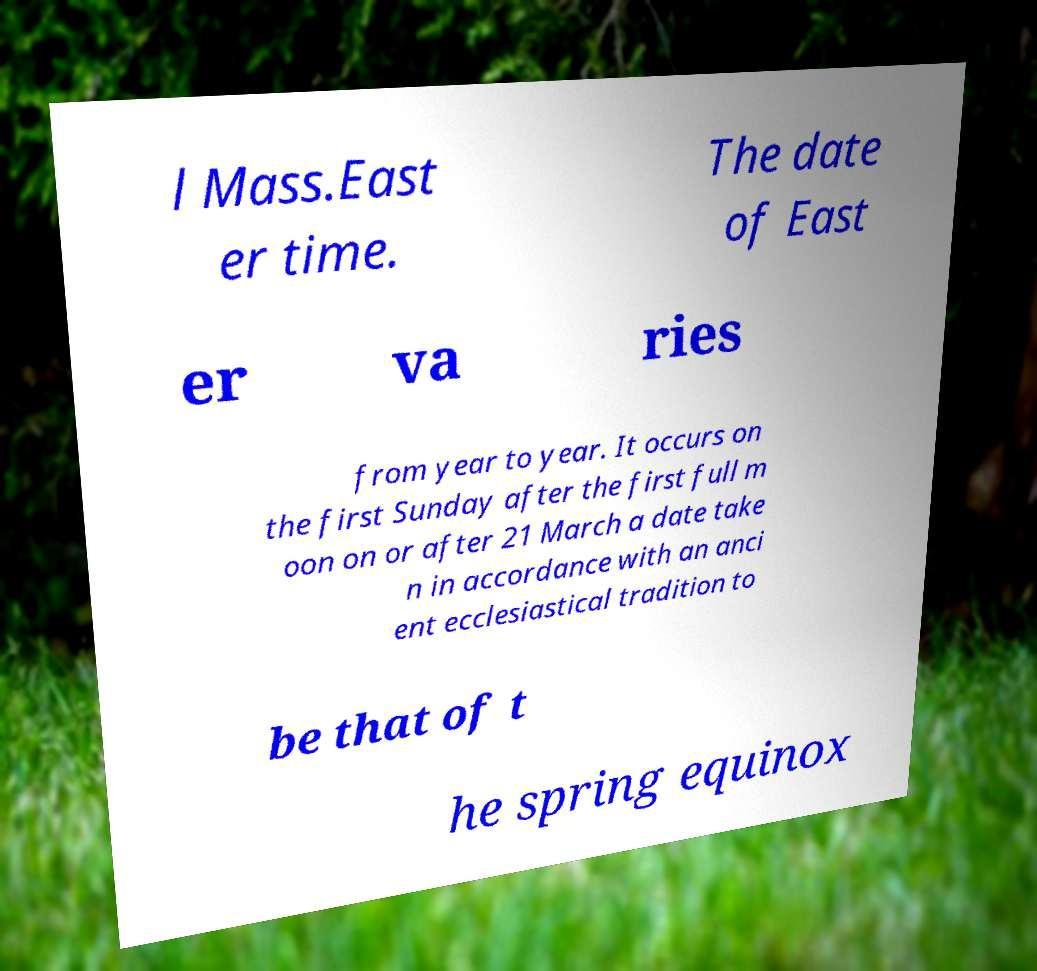What messages or text are displayed in this image? I need them in a readable, typed format. l Mass.East er time. The date of East er va ries from year to year. It occurs on the first Sunday after the first full m oon on or after 21 March a date take n in accordance with an anci ent ecclesiastical tradition to be that of t he spring equinox 